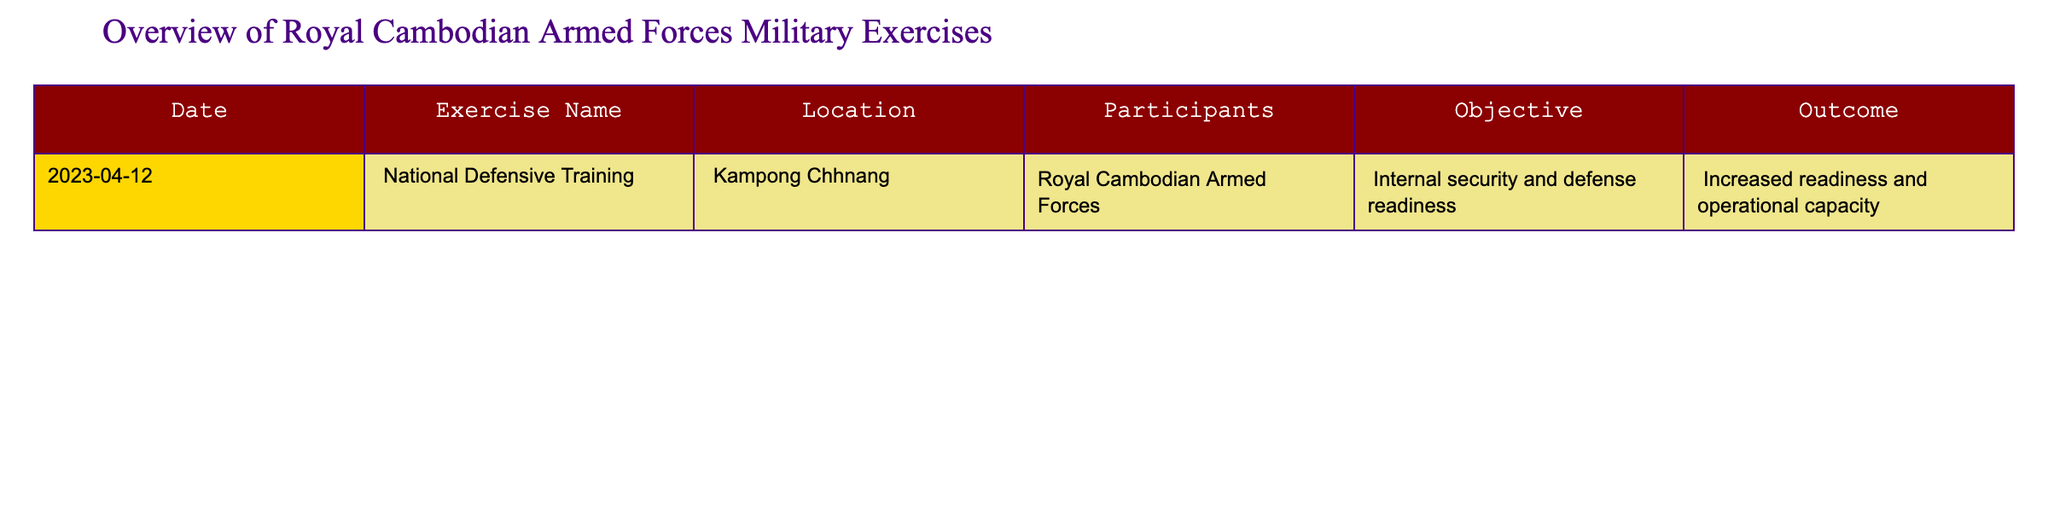What is the date of the National Defensive Training exercise? The table lists the date for the National Defensive Training exercise as April 12, 2023.
Answer: April 12, 2023 Where did the National Defensive Training take place? According to the table, the location for the National Defensive Training was Kampong Chhnang.
Answer: Kampong Chhnang What was the main objective of the National Defensive Training? The objective listed for the National Defensive Training exercise is to ensure internal security and defense readiness.
Answer: Internal security and defense readiness How many participants were involved in the National Defensive Training? The table specifies that the participants for the National Defensive Training exercise were the Royal Cambodian Armed Forces, which indicates that there was one participant group.
Answer: Royal Cambodian Armed Forces What was the outcome of the National Defensive Training exercise? The outcome for the National Defensive Training is described as increased readiness and operational capacity.
Answer: Increased readiness and operational capacity Is there any other military exercise listed besides the National Defensive Training? The table only lists the National Defensive Training exercise, indicating that there are no other exercises recorded in the timeframe.
Answer: No Did the National Defensive Training exercise have a positive outcome? Given that the outcome indicated increased readiness and operational capacity, we can conclude that it had a positive outcome.
Answer: Yes What is the difference between the number of exercises conducted and the number of participants? There is only one exercise listed (National Defensive Training) and one participant group (Royal Cambodian Armed Forces), making the difference 1-1=0.
Answer: 0 What can we infer about the focus of military training exercises based on the National Defensive Training's outcome? The outcome of increased readiness and operational capacity suggests a focus on enhancing internal security and defense proficiency within the Royal Cambodian Armed Forces.
Answer: Focus on enhancing internal security and defense proficiency How might the location of the exercise impact the training outcomes? Conducting training in Kampong Chhnang may provide strategic advantages for internal security and address regional-specific challenges, potentially influencing operational capacity positively.
Answer: It may provide strategic advantages and address specific challenges 